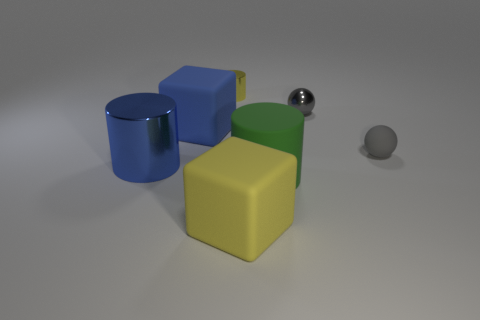Subtract all small yellow cylinders. How many cylinders are left? 2 Add 2 blue cubes. How many objects exist? 9 Subtract all blocks. How many objects are left? 5 Subtract all green cylinders. How many cylinders are left? 2 Subtract all cyan spheres. Subtract all yellow blocks. How many spheres are left? 2 Subtract all metal balls. Subtract all rubber things. How many objects are left? 2 Add 7 yellow metal cylinders. How many yellow metal cylinders are left? 8 Add 1 cyan matte cubes. How many cyan matte cubes exist? 1 Subtract 0 brown cubes. How many objects are left? 7 